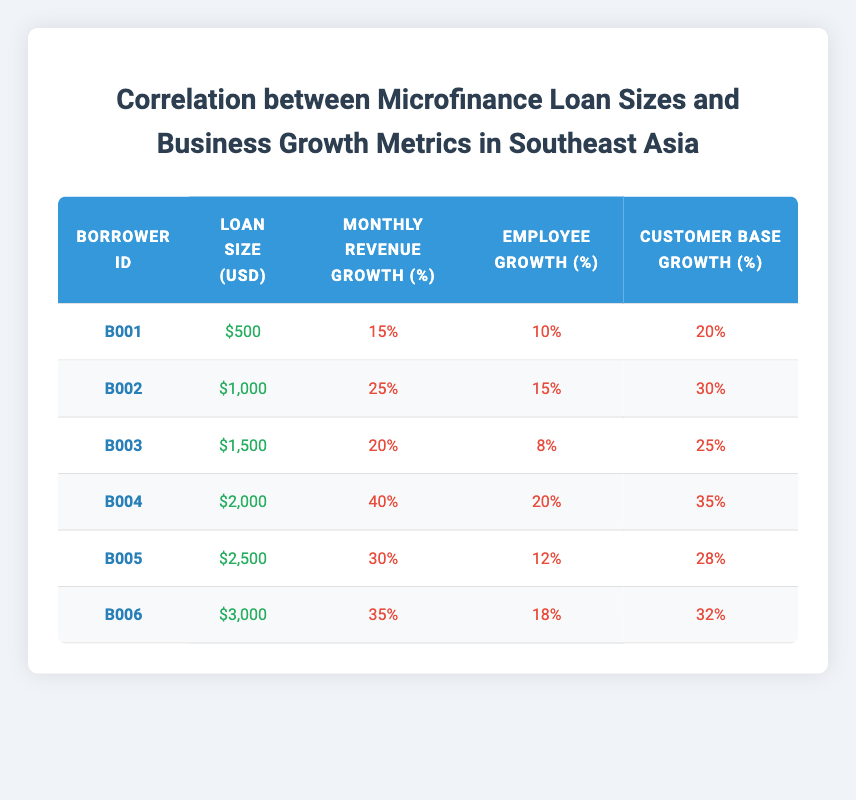What is the loan size of borrower B004? From the table, the loan size associated with borrower B004 is listed directly in the "Loan Size (USD)" column.
Answer: 2000 Which borrower has the highest monthly revenue growth percentage? By examining the "Monthly Revenue Growth (%)" column, B004 has the highest value of 40%, indicating it has the most significant revenue growth compared to others.
Answer: B004 What is the average employee growth percentage across all borrowers? To calculate the average employee growth, sum the employee growth percentages: 10 + 15 + 8 + 20 + 12 + 18 = 83. Dividing this sum by the number of borrowers (6) gives an average of 83/6 = 13.83%.
Answer: 13.83 Is there a borrower with a loan size of 3000 USD? We can look through the "Loan Size (USD)" column to confirm if any entry matches 3000 USD. B006 has a loan size of 3000 USD, so the answer is yes.
Answer: Yes Which borrower has the lowest customer base growth percentage? By analyzing the "Customer Base Growth (%)" column, we find that B003 has the lowest customer base growth at 25%.
Answer: B003 What is the difference in monthly revenue growth percentage between the borrowers with the lowest and highest loan sizes? The lowest loan size is for B001 at 500 USD with a monthly revenue growth of 15%. The highest loan size is for B006 at 3000 USD with a monthly revenue growth of 35%. The difference is 35% - 15% = 20%.
Answer: 20% How many borrowers have an employee growth percentage greater than 15%? We review the "Employee Growth (%)" column to find those above 15%. B002 (15%), B004 (20%), and B006 (18%) qualify, resulting in a count of 3 borrowers.
Answer: 3 What is the total customer base growth percentage for borrowers B002 and B004? For B002, the customer base growth percentage is 30%, and for B004, it is 35%. The total is 30% + 35% = 65%.
Answer: 65 Are there any borrowers whose loan sizes are below 2000 USD? Looking through the "Loan Size (USD)" column, borrowers B001 (500), B002 (1000), and B003 (1500) all have loan sizes below 2000 USD, confirming the answer is yes.
Answer: Yes 